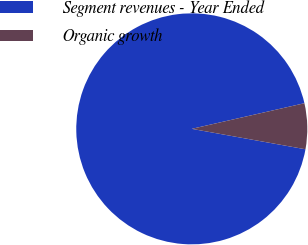<chart> <loc_0><loc_0><loc_500><loc_500><pie_chart><fcel>Segment revenues - Year Ended<fcel>Organic growth<nl><fcel>93.61%<fcel>6.39%<nl></chart> 